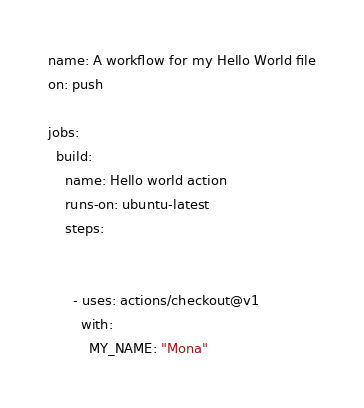<code> <loc_0><loc_0><loc_500><loc_500><_YAML_>name: A workflow for my Hello World file
on: push

jobs:
  build:
    name: Hello world action
    runs-on: ubuntu-latest
    steps:
          
          
      - uses: actions/checkout@v1
        with:
          MY_NAME: "Mona"</code> 